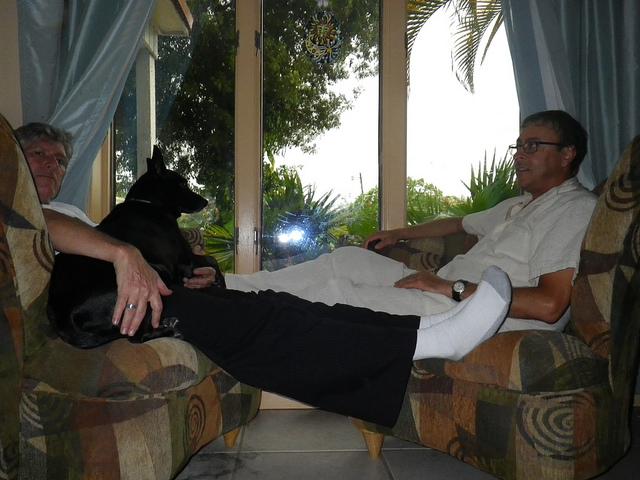Is the dog black?
Keep it brief. Yes. Where is the dog sitting?
Write a very short answer. Chair. Which person is wearing a watch?
Answer briefly. Man. 